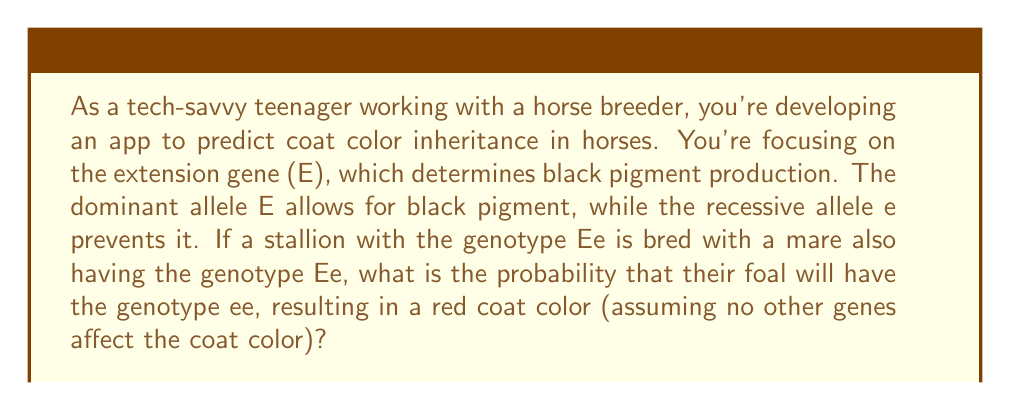Can you answer this question? To solve this problem, we'll use a Punnett square, which is a diagram used to predict the possible genotypes of offspring based on the genotypes of the parents.

1. First, let's set up the Punnett square:

   $$\begin{array}{c|c|c}
    & E & e \\
   \hline
   E & EE & Ee \\
   \hline
   e & Ee & ee
   \end{array}$$

2. In this Punnett square:
   - The top row represents the possible alleles from the stallion (Ee)
   - The left column represents the possible alleles from the mare (Ee)
   - Each cell represents a possible genotype of the offspring

3. To calculate the probability of the foal having the genotype ee:
   - Count the number of ee cells in the Punnett square: There is 1 ee cell
   - Count the total number of cells: There are 4 cells in total

4. The probability is calculated by dividing the favorable outcomes by the total possible outcomes:

   $$P(ee) = \frac{\text{Number of ee cells}}{\text{Total number of cells}} = \frac{1}{4} = 0.25 = 25\%$$

Therefore, there is a 25% chance that the foal will have the genotype ee, resulting in a red coat color.
Answer: The probability that the foal will have the genotype ee is $\frac{1}{4}$ or 25%. 